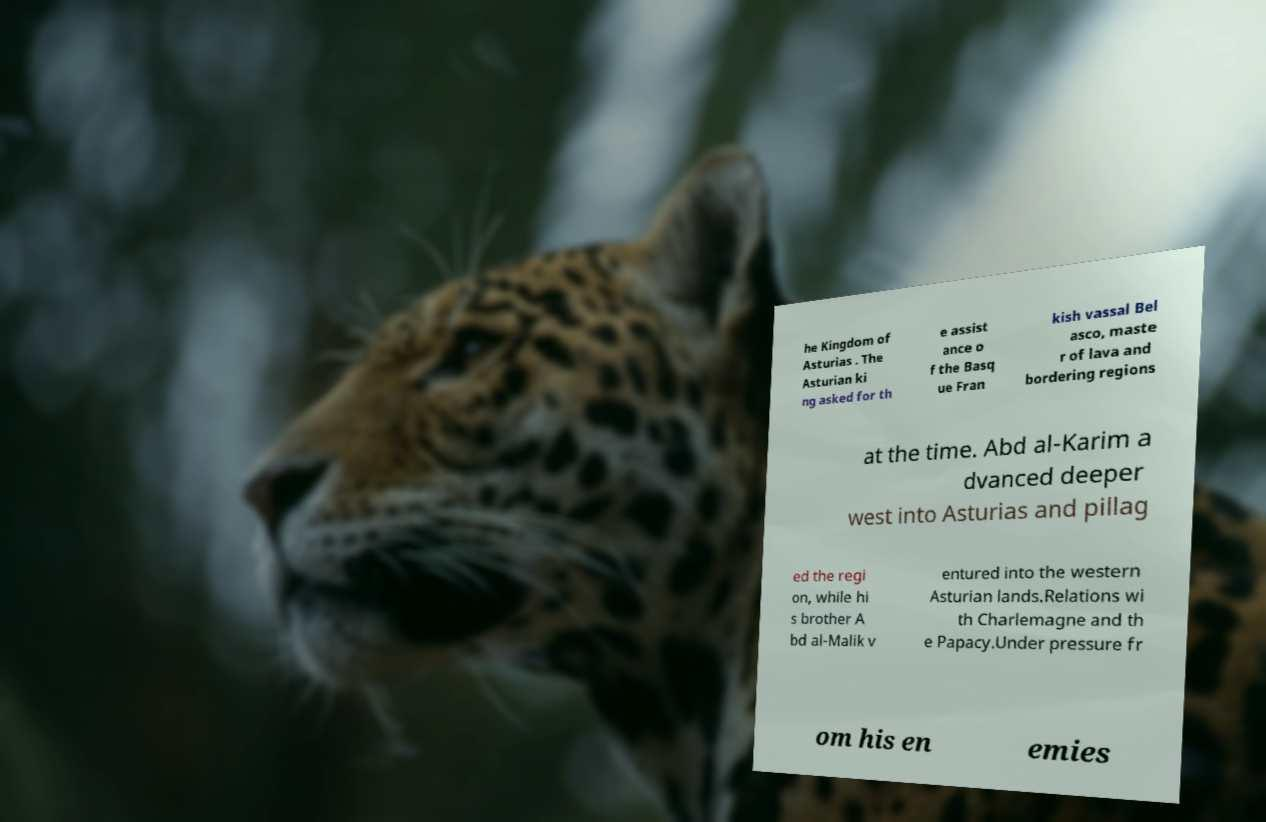Can you accurately transcribe the text from the provided image for me? he Kingdom of Asturias . The Asturian ki ng asked for th e assist ance o f the Basq ue Fran kish vassal Bel asco, maste r of lava and bordering regions at the time. Abd al-Karim a dvanced deeper west into Asturias and pillag ed the regi on, while hi s brother A bd al-Malik v entured into the western Asturian lands.Relations wi th Charlemagne and th e Papacy.Under pressure fr om his en emies 